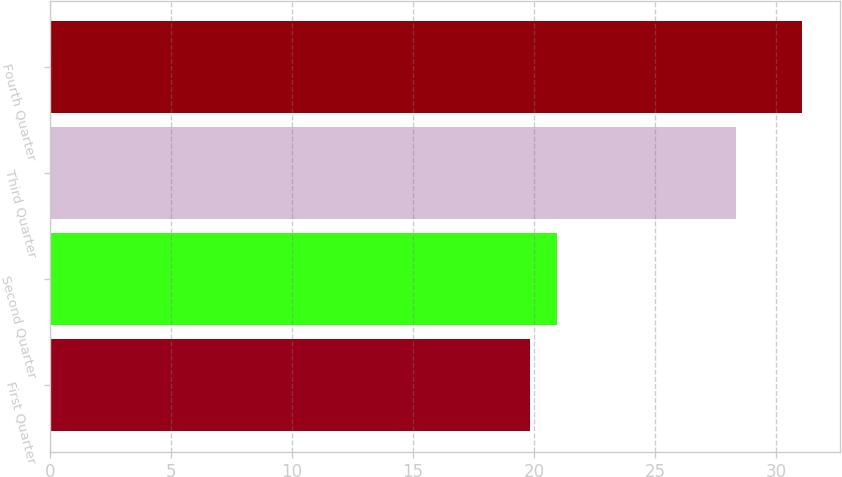Convert chart. <chart><loc_0><loc_0><loc_500><loc_500><bar_chart><fcel>First Quarter<fcel>Second Quarter<fcel>Third Quarter<fcel>Fourth Quarter<nl><fcel>19.84<fcel>20.96<fcel>28.33<fcel>31.09<nl></chart> 